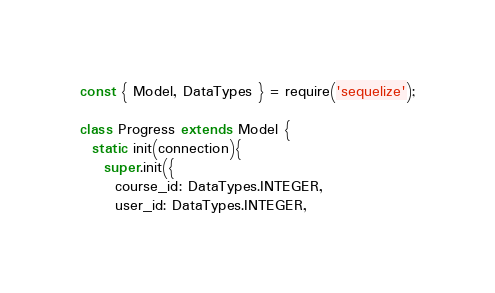Convert code to text. <code><loc_0><loc_0><loc_500><loc_500><_JavaScript_>const { Model, DataTypes } = require('sequelize');

class Progress extends Model {
  static init(connection){
    super.init({
      course_id: DataTypes.INTEGER,
      user_id: DataTypes.INTEGER,</code> 